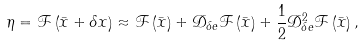<formula> <loc_0><loc_0><loc_500><loc_500>\eta = \mathcal { F } \left ( \bar { x } + \delta x \right ) \approx \mathcal { F } \left ( \bar { x } \right ) + \mathcal { D } _ { \delta e } \mathcal { F } \left ( \bar { x } \right ) + \frac { 1 } { 2 } \mathcal { D } _ { \delta e } ^ { 2 } \mathcal { F } \left ( \bar { x } \right ) ,</formula> 